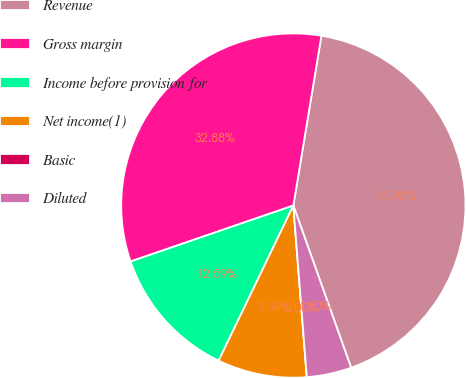Convert chart to OTSL. <chart><loc_0><loc_0><loc_500><loc_500><pie_chart><fcel>Revenue<fcel>Gross margin<fcel>Income before provision for<fcel>Net income(1)<fcel>Basic<fcel>Diluted<nl><fcel>41.95%<fcel>32.88%<fcel>12.59%<fcel>8.39%<fcel>0.0%<fcel>4.2%<nl></chart> 